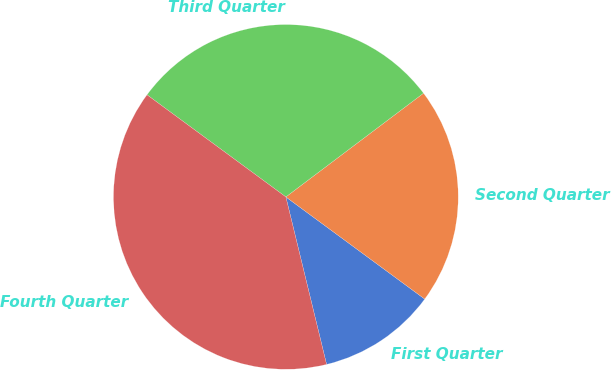Convert chart to OTSL. <chart><loc_0><loc_0><loc_500><loc_500><pie_chart><fcel>First Quarter<fcel>Second Quarter<fcel>Third Quarter<fcel>Fourth Quarter<nl><fcel>11.11%<fcel>20.37%<fcel>29.63%<fcel>38.89%<nl></chart> 